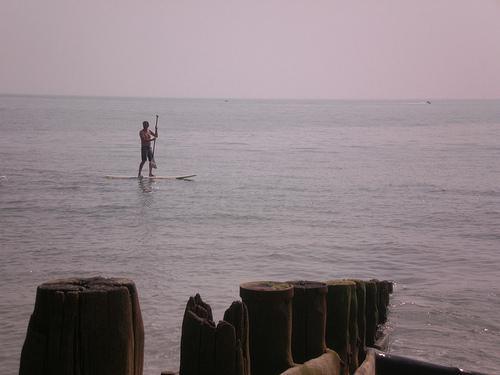Question: where was the photo taken?
Choices:
A. A river.
B. A beach.
C. A lake.
D. A pond.
Answer with the letter. Answer: B Question: what is the man standing on?
Choices:
A. Surfboard.
B. Bricks.
C. Benches.
D. Paddle board.
Answer with the letter. Answer: A Question: who is in the water?
Choices:
A. The man.
B. The woman.
C. The toddler.
D. The dog.
Answer with the letter. Answer: A Question: why is it so dark?
Choices:
A. No moon.
B. Winter time.
C. In the middle of the woods.
D. Sun going down.
Answer with the letter. Answer: D Question: when was the photo taken?
Choices:
A. Afternoon.
B. Morning.
C. Night time.
D. Evening.
Answer with the letter. Answer: A 